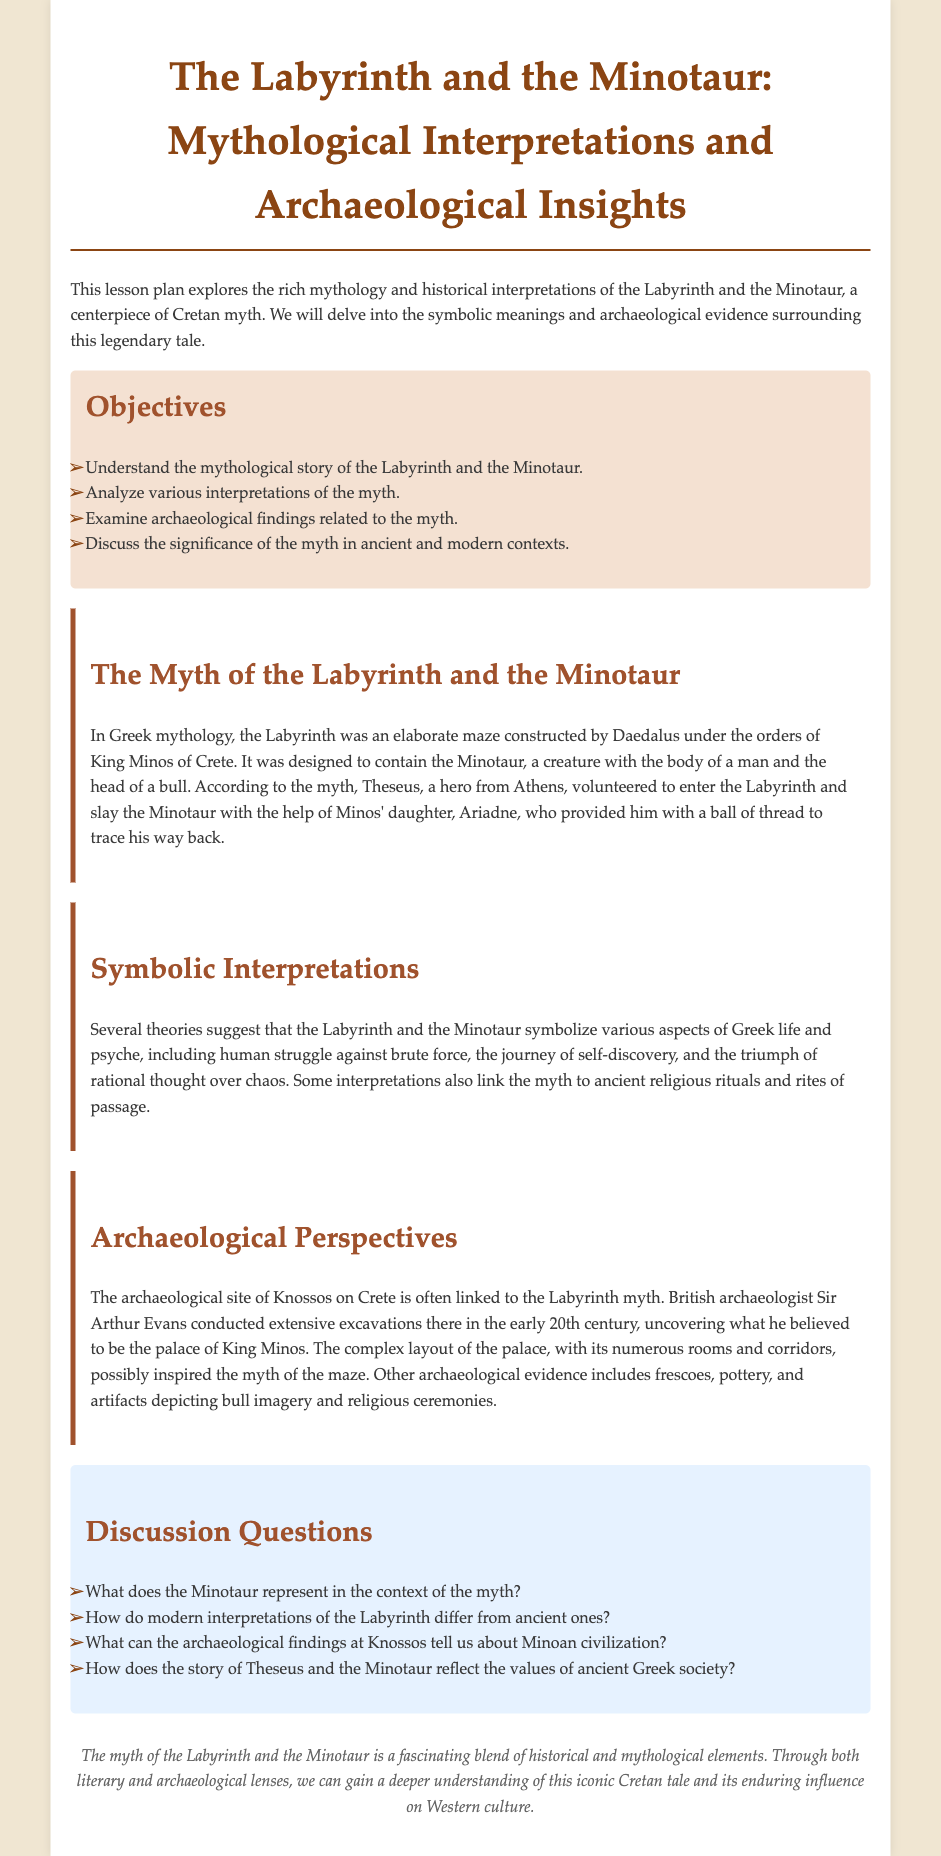What is the title of the lesson plan? The title is stated at the top of the document, clearly identifying the focus area of study.
Answer: The Labyrinth and the Minotaur: Mythological Interpretations and Archaeological Insights Who constructed the Labyrinth? The document states that Daedalus was the architect responsible for building the Labyrinth under the orders of King Minos.
Answer: Daedalus What type of creature is the Minotaur? The document describes the Minotaur as having the body of a man and the head of a bull.
Answer: Man and bull Who helped Theseus navigate the Labyrinth? According to the document, Theseus was assisted by Minos' daughter, who provided him with a crucial item for navigation.
Answer: Ariadne What archaeological site is linked to the myth of the Labyrinth? The document specifies a significant site in Crete that is often associated with the myth and its historical context.
Answer: Knossos What does the Labyrinth symbolize according to various theories? The document mentions several themes that the Labyrinth represents, indicating the complexity of its symbolic meaning.
Answer: Human struggle How many objectives are outlined in the lesson plan? The document lists a total that outlines the educational goals of the lesson pertaining to the myth and its interpretations.
Answer: Four What is the overarching theme of the discussion questions? The document indicates that the discussion questions focus on understanding the myth and its broader implications in culture and society.
Answer: Myth interpretation In what century did Sir Arthur Evans conduct excavations at Knossos? The document mentions the era in which significant archaeological work was undertaken by Evans, thus revealing its historical relevance.
Answer: Early 20th century 